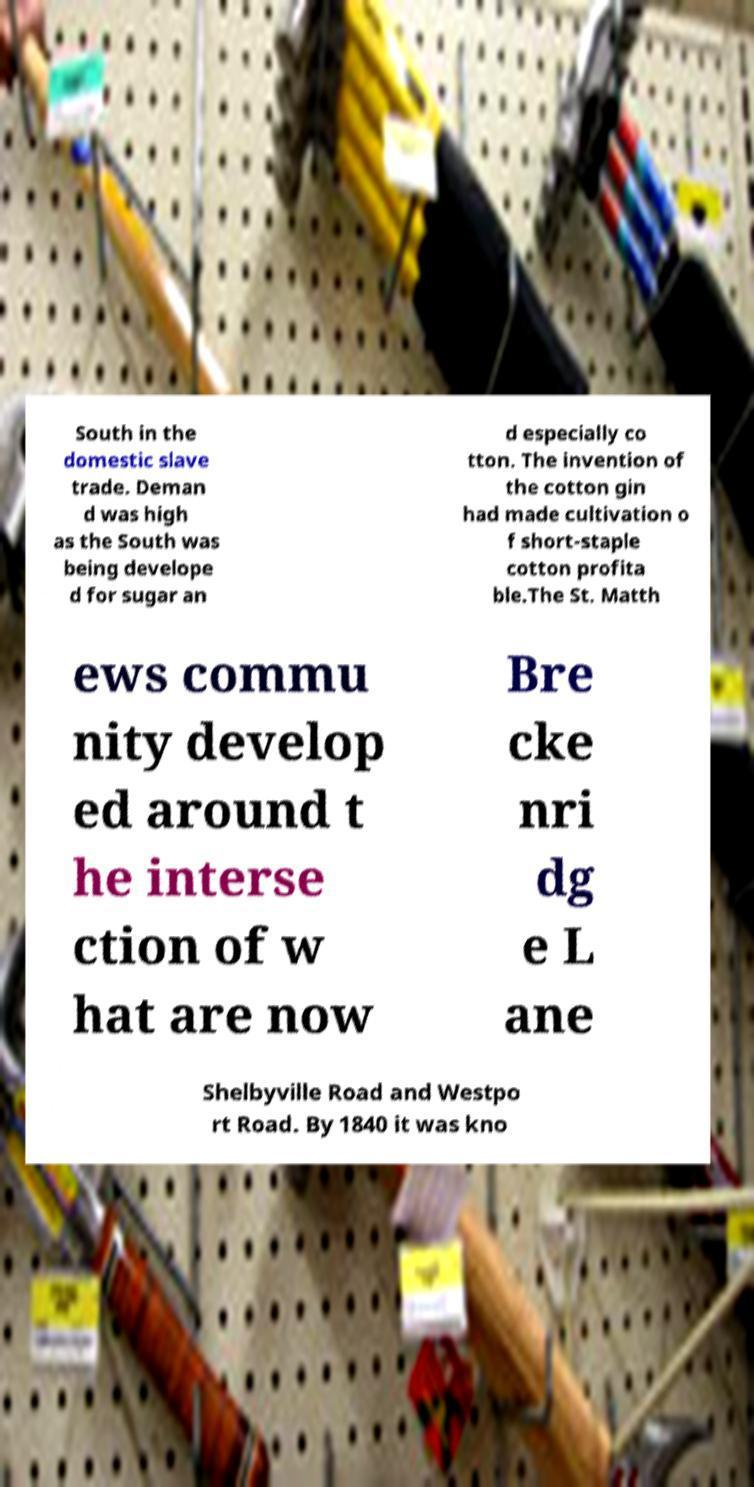Please read and relay the text visible in this image. What does it say? South in the domestic slave trade. Deman d was high as the South was being develope d for sugar an d especially co tton. The invention of the cotton gin had made cultivation o f short-staple cotton profita ble.The St. Matth ews commu nity develop ed around t he interse ction of w hat are now Bre cke nri dg e L ane Shelbyville Road and Westpo rt Road. By 1840 it was kno 